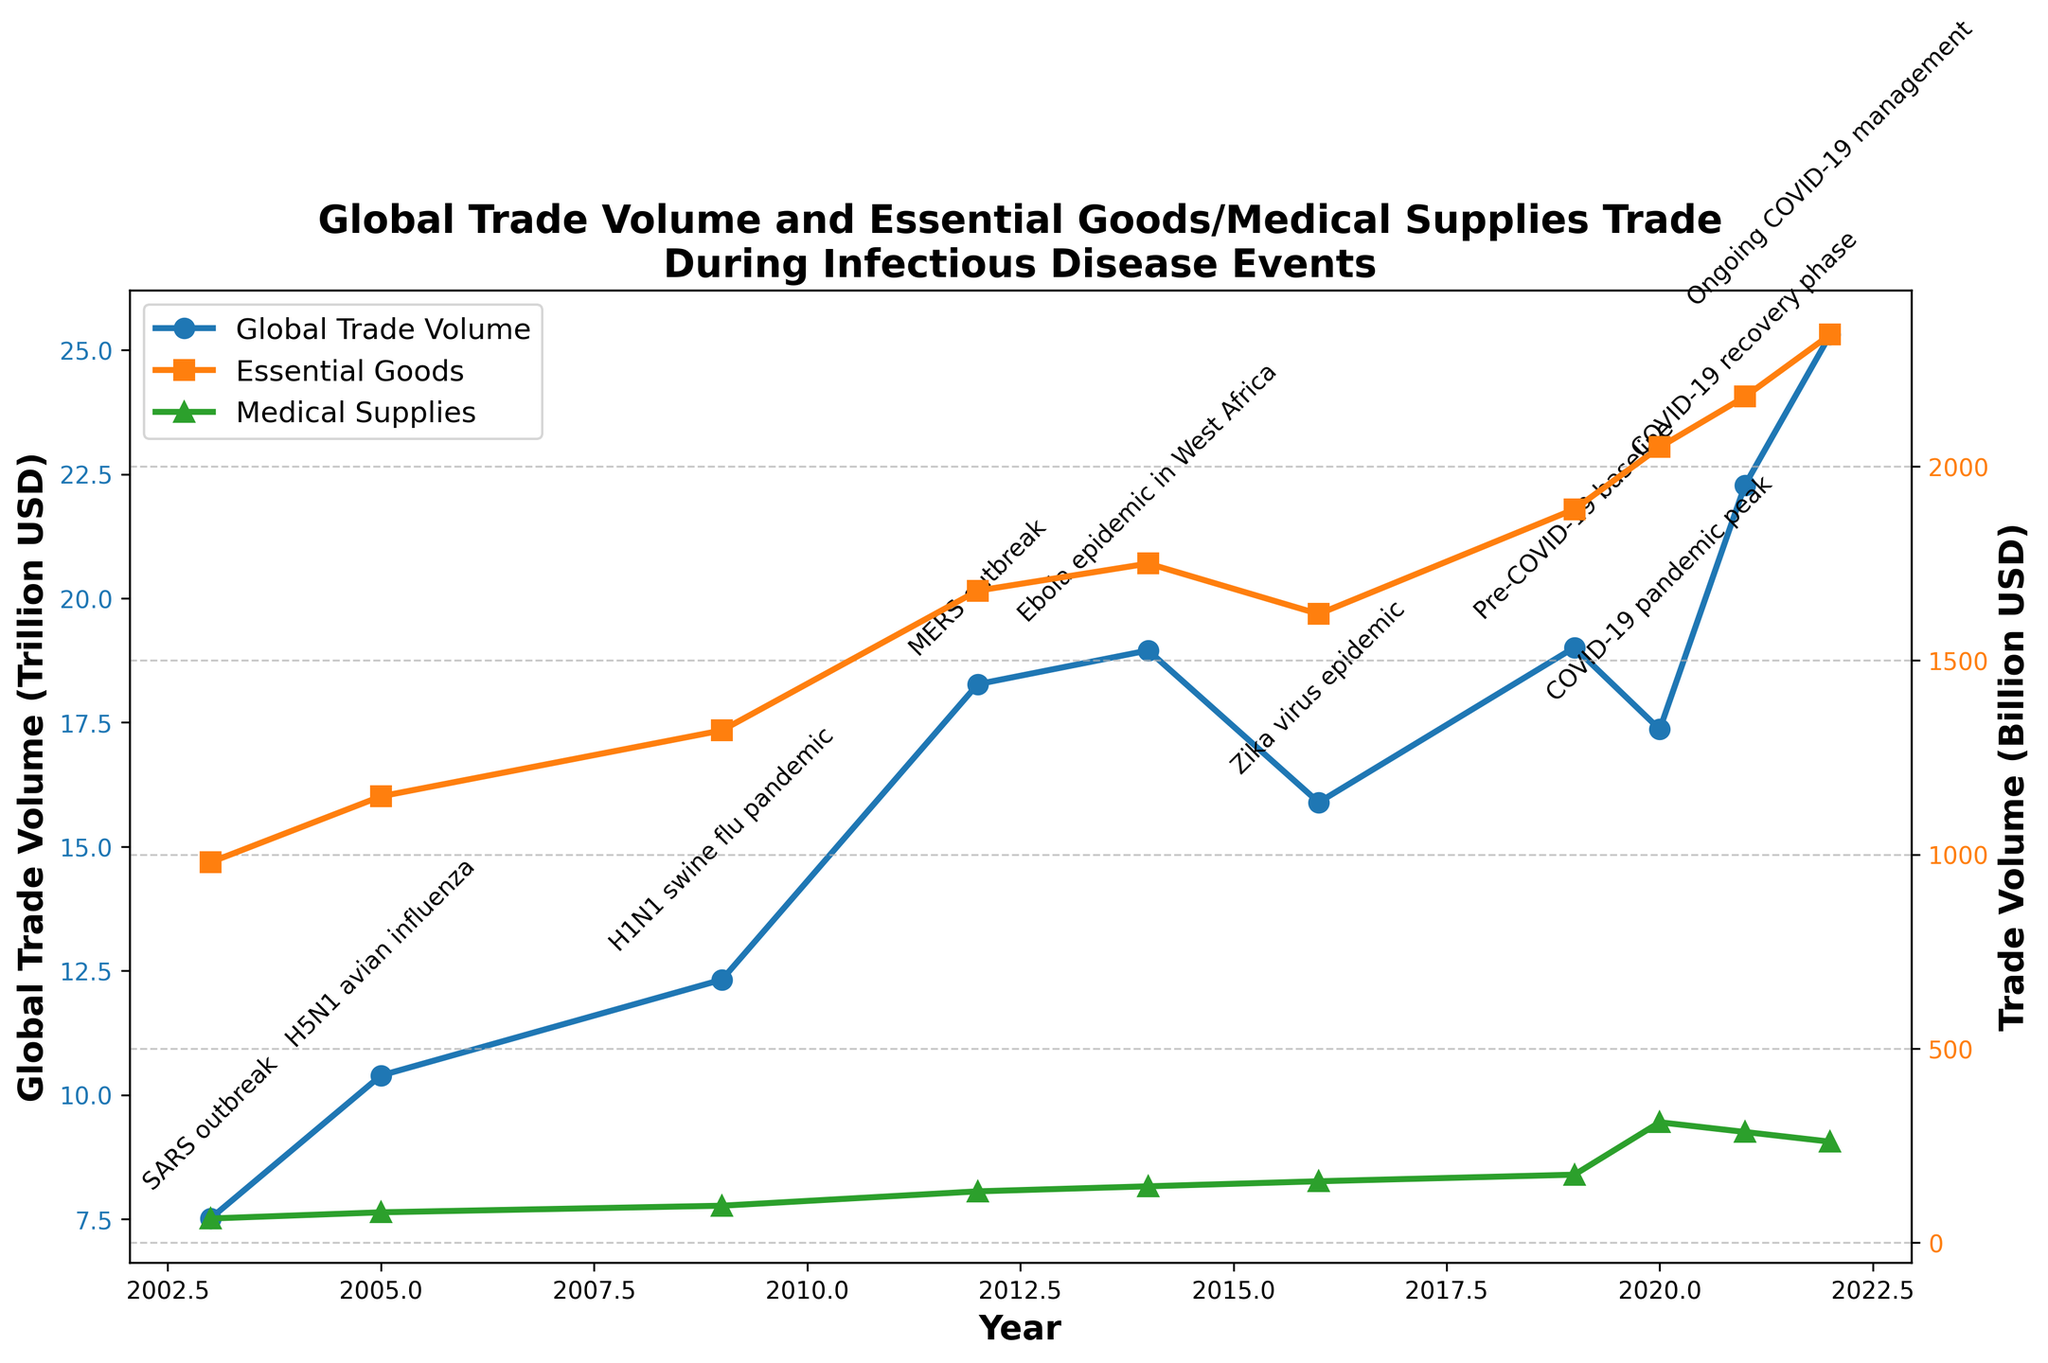Which year had the highest global trade volume? The plot indicates global trade volume trends over the years. The peak is at 2022 with the highest value.
Answer: 2022 Compared to the year 2003, how much did the global trade volume increase by 2022? The global trade volume in 2003 was 7.51 Trillion USD and in 2022 was 25.31 Trillion USD. The increase is 25.31 - 7.51 = 17.8 Trillion USD.
Answer: 17.8 Trillion USD What is the difference between essential goods trade volume and medical supplies trade volume at the peak of the COVID-19 pandemic in 2020? In 2020, essential goods trade volume was 2050 Billion USD, and medical supplies trade volume was 310 Billion USD. The difference is 2050 - 310 = 1740 Billion USD.
Answer: 1740 Billion USD Which infectious disease event correlated with the highest increase in medical supplies trade volume? The plot markers indicate the medical supplies trade volume over infectious disease events. The largest jump in trade volume occurs during the COVID-19 pandemic peak in 2020.
Answer: COVID-19 pandemic Did the global trade volume increase or decrease during the Zika virus epidemic in 2016 compared to 2014? By observing the global trade volume line, the value decreased from 18.95 Trillion USD in 2014 to 15.89 Trillion USD in 2016.
Answer: Decrease How much did the essential goods trade volume change between the SARS outbreak in 2003 and the pre-COVID-19 baseline in 2019? Essential goods trade volume was 980 Billion USD in 2003 and 1890 Billion USD in 2019. The change is 1890 - 980 = 910 Billion USD.
Answer: 910 Billion USD During which year of the dataset did the medical supplies trade volume reach its highest level? The green markers on the plot exhibit the trend of medical supplies trade volume. The highest point is in 2020 with 310 Billion USD.
Answer: 2020 What is the average global trade volume from 2014 to 2022? The values over the specified range are 18.95, 15.89, 19.01, 17.36, 22.28, and 25.31 Trillion USD. The average is (18.95 + 15.89 + 19.01 + 17.36 + 22.28 + 25.31) / 6 = 19.80 Trillion USD.
Answer: 19.80 Trillion USD Which event caused the global trade volume to drop the most in consecutive years? Comparing consecutive year differences, the sharpest drop is from 2014 to 2016 during the Zika virus epidemic, where it fell from 18.95 to 15.89 Trillion USD.
Answer: Zika virus epidemic 